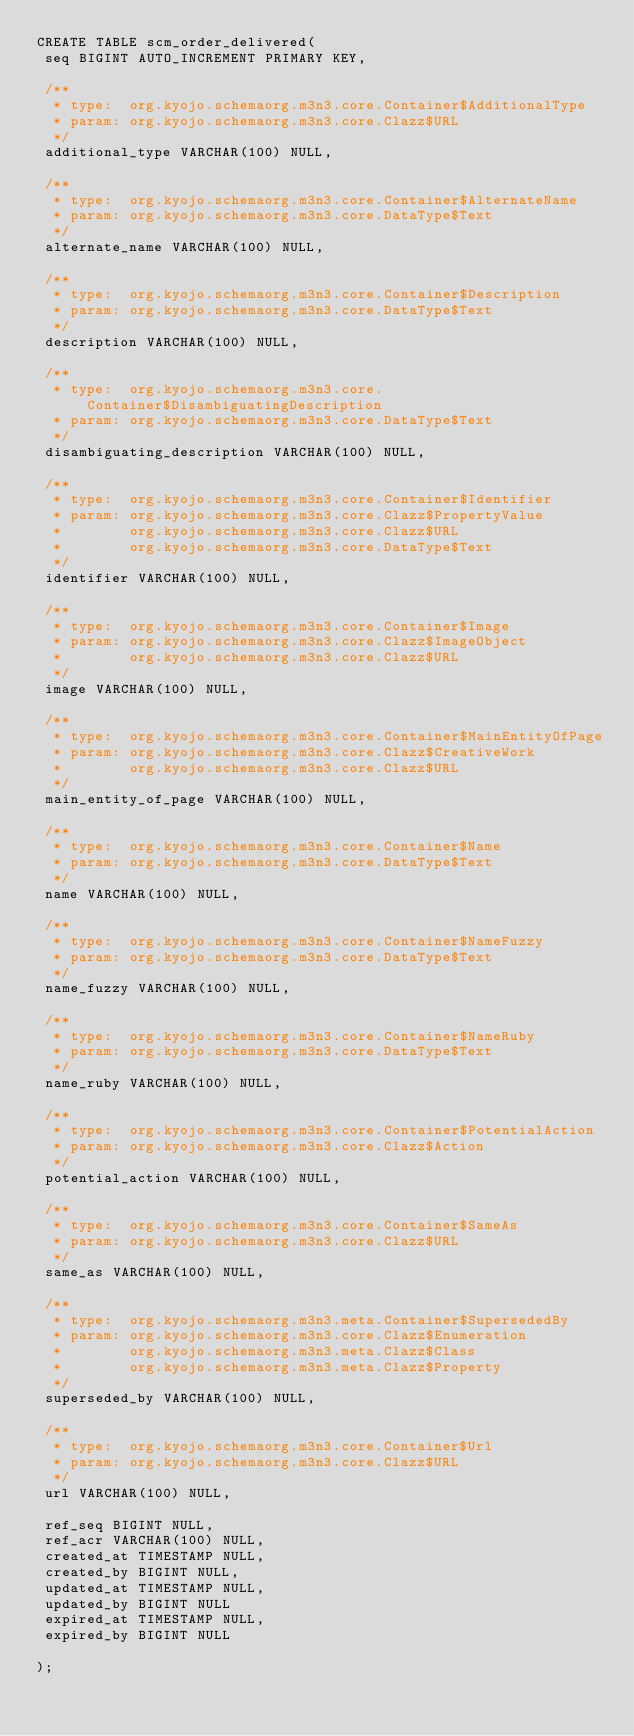<code> <loc_0><loc_0><loc_500><loc_500><_SQL_>CREATE TABLE scm_order_delivered(
 seq BIGINT AUTO_INCREMENT PRIMARY KEY,

 /**
  * type:  org.kyojo.schemaorg.m3n3.core.Container$AdditionalType
  * param: org.kyojo.schemaorg.m3n3.core.Clazz$URL
  */
 additional_type VARCHAR(100) NULL,

 /**
  * type:  org.kyojo.schemaorg.m3n3.core.Container$AlternateName
  * param: org.kyojo.schemaorg.m3n3.core.DataType$Text
  */
 alternate_name VARCHAR(100) NULL,

 /**
  * type:  org.kyojo.schemaorg.m3n3.core.Container$Description
  * param: org.kyojo.schemaorg.m3n3.core.DataType$Text
  */
 description VARCHAR(100) NULL,

 /**
  * type:  org.kyojo.schemaorg.m3n3.core.Container$DisambiguatingDescription
  * param: org.kyojo.schemaorg.m3n3.core.DataType$Text
  */
 disambiguating_description VARCHAR(100) NULL,

 /**
  * type:  org.kyojo.schemaorg.m3n3.core.Container$Identifier
  * param: org.kyojo.schemaorg.m3n3.core.Clazz$PropertyValue
  *        org.kyojo.schemaorg.m3n3.core.Clazz$URL
  *        org.kyojo.schemaorg.m3n3.core.DataType$Text
  */
 identifier VARCHAR(100) NULL,

 /**
  * type:  org.kyojo.schemaorg.m3n3.core.Container$Image
  * param: org.kyojo.schemaorg.m3n3.core.Clazz$ImageObject
  *        org.kyojo.schemaorg.m3n3.core.Clazz$URL
  */
 image VARCHAR(100) NULL,

 /**
  * type:  org.kyojo.schemaorg.m3n3.core.Container$MainEntityOfPage
  * param: org.kyojo.schemaorg.m3n3.core.Clazz$CreativeWork
  *        org.kyojo.schemaorg.m3n3.core.Clazz$URL
  */
 main_entity_of_page VARCHAR(100) NULL,

 /**
  * type:  org.kyojo.schemaorg.m3n3.core.Container$Name
  * param: org.kyojo.schemaorg.m3n3.core.DataType$Text
  */
 name VARCHAR(100) NULL,

 /**
  * type:  org.kyojo.schemaorg.m3n3.core.Container$NameFuzzy
  * param: org.kyojo.schemaorg.m3n3.core.DataType$Text
  */
 name_fuzzy VARCHAR(100) NULL,

 /**
  * type:  org.kyojo.schemaorg.m3n3.core.Container$NameRuby
  * param: org.kyojo.schemaorg.m3n3.core.DataType$Text
  */
 name_ruby VARCHAR(100) NULL,

 /**
  * type:  org.kyojo.schemaorg.m3n3.core.Container$PotentialAction
  * param: org.kyojo.schemaorg.m3n3.core.Clazz$Action
  */
 potential_action VARCHAR(100) NULL,

 /**
  * type:  org.kyojo.schemaorg.m3n3.core.Container$SameAs
  * param: org.kyojo.schemaorg.m3n3.core.Clazz$URL
  */
 same_as VARCHAR(100) NULL,

 /**
  * type:  org.kyojo.schemaorg.m3n3.meta.Container$SupersededBy
  * param: org.kyojo.schemaorg.m3n3.core.Clazz$Enumeration
  *        org.kyojo.schemaorg.m3n3.meta.Clazz$Class
  *        org.kyojo.schemaorg.m3n3.meta.Clazz$Property
  */
 superseded_by VARCHAR(100) NULL,

 /**
  * type:  org.kyojo.schemaorg.m3n3.core.Container$Url
  * param: org.kyojo.schemaorg.m3n3.core.Clazz$URL
  */
 url VARCHAR(100) NULL,

 ref_seq BIGINT NULL,
 ref_acr VARCHAR(100) NULL,
 created_at TIMESTAMP NULL,
 created_by BIGINT NULL,
 updated_at TIMESTAMP NULL,
 updated_by BIGINT NULL
 expired_at TIMESTAMP NULL,
 expired_by BIGINT NULL

);</code> 